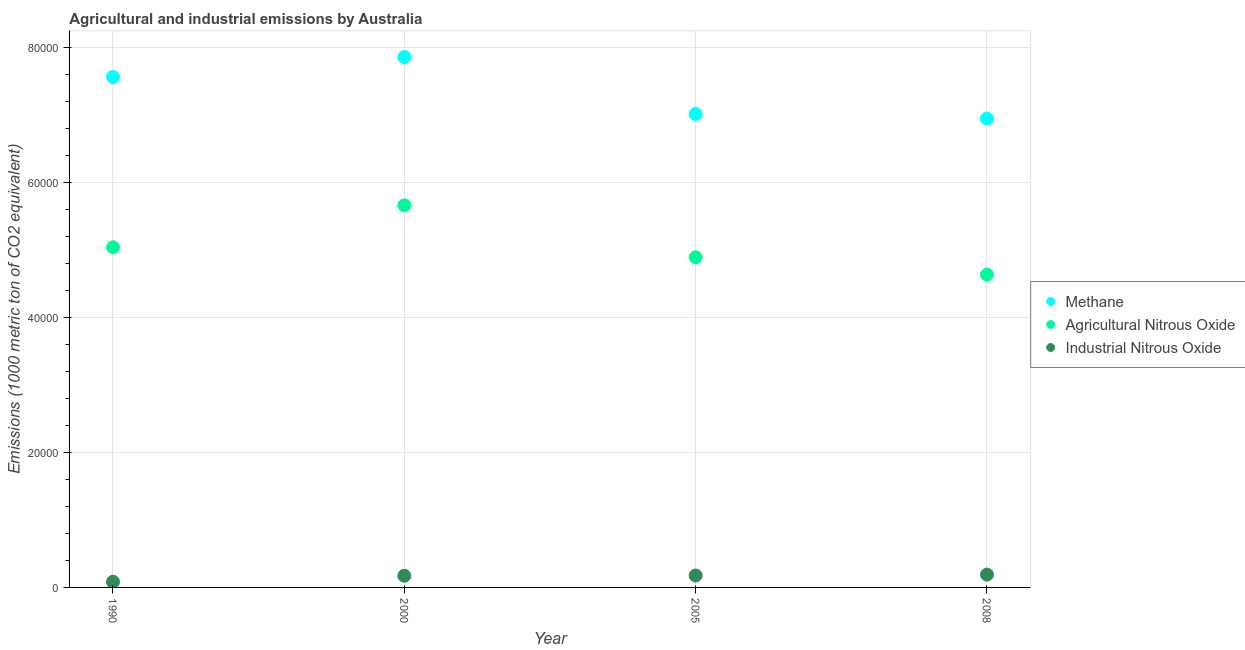How many different coloured dotlines are there?
Make the answer very short. 3. What is the amount of industrial nitrous oxide emissions in 2008?
Provide a short and direct response. 1903.1. Across all years, what is the maximum amount of methane emissions?
Make the answer very short. 7.85e+04. Across all years, what is the minimum amount of industrial nitrous oxide emissions?
Give a very brief answer. 839.8. In which year was the amount of methane emissions minimum?
Make the answer very short. 2008. What is the total amount of methane emissions in the graph?
Offer a terse response. 2.94e+05. What is the difference between the amount of industrial nitrous oxide emissions in 2000 and that in 2008?
Offer a very short reply. -173.3. What is the difference between the amount of agricultural nitrous oxide emissions in 2005 and the amount of methane emissions in 2008?
Your response must be concise. -2.05e+04. What is the average amount of industrial nitrous oxide emissions per year?
Ensure brevity in your answer.  1559.55. In the year 2005, what is the difference between the amount of agricultural nitrous oxide emissions and amount of industrial nitrous oxide emissions?
Provide a short and direct response. 4.71e+04. What is the ratio of the amount of agricultural nitrous oxide emissions in 2000 to that in 2005?
Your response must be concise. 1.16. Is the difference between the amount of agricultural nitrous oxide emissions in 2000 and 2008 greater than the difference between the amount of industrial nitrous oxide emissions in 2000 and 2008?
Offer a very short reply. Yes. What is the difference between the highest and the second highest amount of methane emissions?
Provide a succinct answer. 2952.5. What is the difference between the highest and the lowest amount of agricultural nitrous oxide emissions?
Offer a very short reply. 1.03e+04. In how many years, is the amount of industrial nitrous oxide emissions greater than the average amount of industrial nitrous oxide emissions taken over all years?
Provide a succinct answer. 3. Is the sum of the amount of agricultural nitrous oxide emissions in 2000 and 2005 greater than the maximum amount of methane emissions across all years?
Offer a very short reply. Yes. Is it the case that in every year, the sum of the amount of methane emissions and amount of agricultural nitrous oxide emissions is greater than the amount of industrial nitrous oxide emissions?
Your answer should be very brief. Yes. Is the amount of methane emissions strictly greater than the amount of industrial nitrous oxide emissions over the years?
Provide a short and direct response. Yes. How many dotlines are there?
Ensure brevity in your answer.  3. How many years are there in the graph?
Provide a short and direct response. 4. What is the difference between two consecutive major ticks on the Y-axis?
Provide a succinct answer. 2.00e+04. How many legend labels are there?
Make the answer very short. 3. How are the legend labels stacked?
Your answer should be very brief. Vertical. What is the title of the graph?
Provide a short and direct response. Agricultural and industrial emissions by Australia. What is the label or title of the Y-axis?
Your answer should be very brief. Emissions (1000 metric ton of CO2 equivalent). What is the Emissions (1000 metric ton of CO2 equivalent) of Methane in 1990?
Ensure brevity in your answer.  7.56e+04. What is the Emissions (1000 metric ton of CO2 equivalent) in Agricultural Nitrous Oxide in 1990?
Provide a short and direct response. 5.04e+04. What is the Emissions (1000 metric ton of CO2 equivalent) of Industrial Nitrous Oxide in 1990?
Provide a succinct answer. 839.8. What is the Emissions (1000 metric ton of CO2 equivalent) in Methane in 2000?
Ensure brevity in your answer.  7.85e+04. What is the Emissions (1000 metric ton of CO2 equivalent) in Agricultural Nitrous Oxide in 2000?
Your response must be concise. 5.66e+04. What is the Emissions (1000 metric ton of CO2 equivalent) in Industrial Nitrous Oxide in 2000?
Ensure brevity in your answer.  1729.8. What is the Emissions (1000 metric ton of CO2 equivalent) of Methane in 2005?
Provide a succinct answer. 7.01e+04. What is the Emissions (1000 metric ton of CO2 equivalent) of Agricultural Nitrous Oxide in 2005?
Your response must be concise. 4.89e+04. What is the Emissions (1000 metric ton of CO2 equivalent) in Industrial Nitrous Oxide in 2005?
Your answer should be very brief. 1765.5. What is the Emissions (1000 metric ton of CO2 equivalent) in Methane in 2008?
Offer a terse response. 6.95e+04. What is the Emissions (1000 metric ton of CO2 equivalent) of Agricultural Nitrous Oxide in 2008?
Your answer should be compact. 4.63e+04. What is the Emissions (1000 metric ton of CO2 equivalent) of Industrial Nitrous Oxide in 2008?
Give a very brief answer. 1903.1. Across all years, what is the maximum Emissions (1000 metric ton of CO2 equivalent) in Methane?
Ensure brevity in your answer.  7.85e+04. Across all years, what is the maximum Emissions (1000 metric ton of CO2 equivalent) of Agricultural Nitrous Oxide?
Offer a very short reply. 5.66e+04. Across all years, what is the maximum Emissions (1000 metric ton of CO2 equivalent) of Industrial Nitrous Oxide?
Keep it short and to the point. 1903.1. Across all years, what is the minimum Emissions (1000 metric ton of CO2 equivalent) of Methane?
Your answer should be very brief. 6.95e+04. Across all years, what is the minimum Emissions (1000 metric ton of CO2 equivalent) in Agricultural Nitrous Oxide?
Offer a very short reply. 4.63e+04. Across all years, what is the minimum Emissions (1000 metric ton of CO2 equivalent) of Industrial Nitrous Oxide?
Your answer should be very brief. 839.8. What is the total Emissions (1000 metric ton of CO2 equivalent) of Methane in the graph?
Give a very brief answer. 2.94e+05. What is the total Emissions (1000 metric ton of CO2 equivalent) of Agricultural Nitrous Oxide in the graph?
Give a very brief answer. 2.02e+05. What is the total Emissions (1000 metric ton of CO2 equivalent) of Industrial Nitrous Oxide in the graph?
Keep it short and to the point. 6238.2. What is the difference between the Emissions (1000 metric ton of CO2 equivalent) of Methane in 1990 and that in 2000?
Make the answer very short. -2952.5. What is the difference between the Emissions (1000 metric ton of CO2 equivalent) of Agricultural Nitrous Oxide in 1990 and that in 2000?
Provide a succinct answer. -6212.8. What is the difference between the Emissions (1000 metric ton of CO2 equivalent) in Industrial Nitrous Oxide in 1990 and that in 2000?
Give a very brief answer. -890. What is the difference between the Emissions (1000 metric ton of CO2 equivalent) of Methane in 1990 and that in 2005?
Provide a short and direct response. 5478.7. What is the difference between the Emissions (1000 metric ton of CO2 equivalent) in Agricultural Nitrous Oxide in 1990 and that in 2005?
Your answer should be very brief. 1475.2. What is the difference between the Emissions (1000 metric ton of CO2 equivalent) in Industrial Nitrous Oxide in 1990 and that in 2005?
Provide a short and direct response. -925.7. What is the difference between the Emissions (1000 metric ton of CO2 equivalent) in Methane in 1990 and that in 2008?
Your answer should be compact. 6145.3. What is the difference between the Emissions (1000 metric ton of CO2 equivalent) in Agricultural Nitrous Oxide in 1990 and that in 2008?
Your answer should be compact. 4045.5. What is the difference between the Emissions (1000 metric ton of CO2 equivalent) of Industrial Nitrous Oxide in 1990 and that in 2008?
Your answer should be very brief. -1063.3. What is the difference between the Emissions (1000 metric ton of CO2 equivalent) in Methane in 2000 and that in 2005?
Provide a short and direct response. 8431.2. What is the difference between the Emissions (1000 metric ton of CO2 equivalent) in Agricultural Nitrous Oxide in 2000 and that in 2005?
Provide a succinct answer. 7688. What is the difference between the Emissions (1000 metric ton of CO2 equivalent) in Industrial Nitrous Oxide in 2000 and that in 2005?
Provide a succinct answer. -35.7. What is the difference between the Emissions (1000 metric ton of CO2 equivalent) in Methane in 2000 and that in 2008?
Your answer should be very brief. 9097.8. What is the difference between the Emissions (1000 metric ton of CO2 equivalent) of Agricultural Nitrous Oxide in 2000 and that in 2008?
Ensure brevity in your answer.  1.03e+04. What is the difference between the Emissions (1000 metric ton of CO2 equivalent) in Industrial Nitrous Oxide in 2000 and that in 2008?
Provide a succinct answer. -173.3. What is the difference between the Emissions (1000 metric ton of CO2 equivalent) of Methane in 2005 and that in 2008?
Your answer should be compact. 666.6. What is the difference between the Emissions (1000 metric ton of CO2 equivalent) of Agricultural Nitrous Oxide in 2005 and that in 2008?
Give a very brief answer. 2570.3. What is the difference between the Emissions (1000 metric ton of CO2 equivalent) of Industrial Nitrous Oxide in 2005 and that in 2008?
Your answer should be compact. -137.6. What is the difference between the Emissions (1000 metric ton of CO2 equivalent) in Methane in 1990 and the Emissions (1000 metric ton of CO2 equivalent) in Agricultural Nitrous Oxide in 2000?
Your response must be concise. 1.90e+04. What is the difference between the Emissions (1000 metric ton of CO2 equivalent) of Methane in 1990 and the Emissions (1000 metric ton of CO2 equivalent) of Industrial Nitrous Oxide in 2000?
Offer a very short reply. 7.39e+04. What is the difference between the Emissions (1000 metric ton of CO2 equivalent) of Agricultural Nitrous Oxide in 1990 and the Emissions (1000 metric ton of CO2 equivalent) of Industrial Nitrous Oxide in 2000?
Your response must be concise. 4.86e+04. What is the difference between the Emissions (1000 metric ton of CO2 equivalent) in Methane in 1990 and the Emissions (1000 metric ton of CO2 equivalent) in Agricultural Nitrous Oxide in 2005?
Your answer should be compact. 2.67e+04. What is the difference between the Emissions (1000 metric ton of CO2 equivalent) of Methane in 1990 and the Emissions (1000 metric ton of CO2 equivalent) of Industrial Nitrous Oxide in 2005?
Offer a very short reply. 7.38e+04. What is the difference between the Emissions (1000 metric ton of CO2 equivalent) in Agricultural Nitrous Oxide in 1990 and the Emissions (1000 metric ton of CO2 equivalent) in Industrial Nitrous Oxide in 2005?
Offer a very short reply. 4.86e+04. What is the difference between the Emissions (1000 metric ton of CO2 equivalent) in Methane in 1990 and the Emissions (1000 metric ton of CO2 equivalent) in Agricultural Nitrous Oxide in 2008?
Offer a very short reply. 2.93e+04. What is the difference between the Emissions (1000 metric ton of CO2 equivalent) in Methane in 1990 and the Emissions (1000 metric ton of CO2 equivalent) in Industrial Nitrous Oxide in 2008?
Offer a very short reply. 7.37e+04. What is the difference between the Emissions (1000 metric ton of CO2 equivalent) of Agricultural Nitrous Oxide in 1990 and the Emissions (1000 metric ton of CO2 equivalent) of Industrial Nitrous Oxide in 2008?
Your response must be concise. 4.85e+04. What is the difference between the Emissions (1000 metric ton of CO2 equivalent) in Methane in 2000 and the Emissions (1000 metric ton of CO2 equivalent) in Agricultural Nitrous Oxide in 2005?
Offer a very short reply. 2.96e+04. What is the difference between the Emissions (1000 metric ton of CO2 equivalent) of Methane in 2000 and the Emissions (1000 metric ton of CO2 equivalent) of Industrial Nitrous Oxide in 2005?
Keep it short and to the point. 7.68e+04. What is the difference between the Emissions (1000 metric ton of CO2 equivalent) in Agricultural Nitrous Oxide in 2000 and the Emissions (1000 metric ton of CO2 equivalent) in Industrial Nitrous Oxide in 2005?
Give a very brief answer. 5.48e+04. What is the difference between the Emissions (1000 metric ton of CO2 equivalent) of Methane in 2000 and the Emissions (1000 metric ton of CO2 equivalent) of Agricultural Nitrous Oxide in 2008?
Provide a short and direct response. 3.22e+04. What is the difference between the Emissions (1000 metric ton of CO2 equivalent) of Methane in 2000 and the Emissions (1000 metric ton of CO2 equivalent) of Industrial Nitrous Oxide in 2008?
Your answer should be very brief. 7.66e+04. What is the difference between the Emissions (1000 metric ton of CO2 equivalent) in Agricultural Nitrous Oxide in 2000 and the Emissions (1000 metric ton of CO2 equivalent) in Industrial Nitrous Oxide in 2008?
Provide a short and direct response. 5.47e+04. What is the difference between the Emissions (1000 metric ton of CO2 equivalent) in Methane in 2005 and the Emissions (1000 metric ton of CO2 equivalent) in Agricultural Nitrous Oxide in 2008?
Ensure brevity in your answer.  2.38e+04. What is the difference between the Emissions (1000 metric ton of CO2 equivalent) of Methane in 2005 and the Emissions (1000 metric ton of CO2 equivalent) of Industrial Nitrous Oxide in 2008?
Make the answer very short. 6.82e+04. What is the difference between the Emissions (1000 metric ton of CO2 equivalent) of Agricultural Nitrous Oxide in 2005 and the Emissions (1000 metric ton of CO2 equivalent) of Industrial Nitrous Oxide in 2008?
Keep it short and to the point. 4.70e+04. What is the average Emissions (1000 metric ton of CO2 equivalent) of Methane per year?
Your answer should be very brief. 7.34e+04. What is the average Emissions (1000 metric ton of CO2 equivalent) in Agricultural Nitrous Oxide per year?
Offer a very short reply. 5.06e+04. What is the average Emissions (1000 metric ton of CO2 equivalent) of Industrial Nitrous Oxide per year?
Offer a very short reply. 1559.55. In the year 1990, what is the difference between the Emissions (1000 metric ton of CO2 equivalent) of Methane and Emissions (1000 metric ton of CO2 equivalent) of Agricultural Nitrous Oxide?
Provide a succinct answer. 2.52e+04. In the year 1990, what is the difference between the Emissions (1000 metric ton of CO2 equivalent) of Methane and Emissions (1000 metric ton of CO2 equivalent) of Industrial Nitrous Oxide?
Ensure brevity in your answer.  7.48e+04. In the year 1990, what is the difference between the Emissions (1000 metric ton of CO2 equivalent) in Agricultural Nitrous Oxide and Emissions (1000 metric ton of CO2 equivalent) in Industrial Nitrous Oxide?
Offer a very short reply. 4.95e+04. In the year 2000, what is the difference between the Emissions (1000 metric ton of CO2 equivalent) of Methane and Emissions (1000 metric ton of CO2 equivalent) of Agricultural Nitrous Oxide?
Your answer should be very brief. 2.20e+04. In the year 2000, what is the difference between the Emissions (1000 metric ton of CO2 equivalent) of Methane and Emissions (1000 metric ton of CO2 equivalent) of Industrial Nitrous Oxide?
Make the answer very short. 7.68e+04. In the year 2000, what is the difference between the Emissions (1000 metric ton of CO2 equivalent) in Agricultural Nitrous Oxide and Emissions (1000 metric ton of CO2 equivalent) in Industrial Nitrous Oxide?
Give a very brief answer. 5.49e+04. In the year 2005, what is the difference between the Emissions (1000 metric ton of CO2 equivalent) of Methane and Emissions (1000 metric ton of CO2 equivalent) of Agricultural Nitrous Oxide?
Ensure brevity in your answer.  2.12e+04. In the year 2005, what is the difference between the Emissions (1000 metric ton of CO2 equivalent) in Methane and Emissions (1000 metric ton of CO2 equivalent) in Industrial Nitrous Oxide?
Provide a short and direct response. 6.84e+04. In the year 2005, what is the difference between the Emissions (1000 metric ton of CO2 equivalent) in Agricultural Nitrous Oxide and Emissions (1000 metric ton of CO2 equivalent) in Industrial Nitrous Oxide?
Make the answer very short. 4.71e+04. In the year 2008, what is the difference between the Emissions (1000 metric ton of CO2 equivalent) in Methane and Emissions (1000 metric ton of CO2 equivalent) in Agricultural Nitrous Oxide?
Your response must be concise. 2.31e+04. In the year 2008, what is the difference between the Emissions (1000 metric ton of CO2 equivalent) of Methane and Emissions (1000 metric ton of CO2 equivalent) of Industrial Nitrous Oxide?
Your answer should be compact. 6.75e+04. In the year 2008, what is the difference between the Emissions (1000 metric ton of CO2 equivalent) in Agricultural Nitrous Oxide and Emissions (1000 metric ton of CO2 equivalent) in Industrial Nitrous Oxide?
Offer a terse response. 4.44e+04. What is the ratio of the Emissions (1000 metric ton of CO2 equivalent) in Methane in 1990 to that in 2000?
Give a very brief answer. 0.96. What is the ratio of the Emissions (1000 metric ton of CO2 equivalent) of Agricultural Nitrous Oxide in 1990 to that in 2000?
Ensure brevity in your answer.  0.89. What is the ratio of the Emissions (1000 metric ton of CO2 equivalent) in Industrial Nitrous Oxide in 1990 to that in 2000?
Your response must be concise. 0.49. What is the ratio of the Emissions (1000 metric ton of CO2 equivalent) of Methane in 1990 to that in 2005?
Your response must be concise. 1.08. What is the ratio of the Emissions (1000 metric ton of CO2 equivalent) in Agricultural Nitrous Oxide in 1990 to that in 2005?
Your response must be concise. 1.03. What is the ratio of the Emissions (1000 metric ton of CO2 equivalent) of Industrial Nitrous Oxide in 1990 to that in 2005?
Your answer should be compact. 0.48. What is the ratio of the Emissions (1000 metric ton of CO2 equivalent) of Methane in 1990 to that in 2008?
Provide a succinct answer. 1.09. What is the ratio of the Emissions (1000 metric ton of CO2 equivalent) of Agricultural Nitrous Oxide in 1990 to that in 2008?
Make the answer very short. 1.09. What is the ratio of the Emissions (1000 metric ton of CO2 equivalent) in Industrial Nitrous Oxide in 1990 to that in 2008?
Offer a very short reply. 0.44. What is the ratio of the Emissions (1000 metric ton of CO2 equivalent) in Methane in 2000 to that in 2005?
Keep it short and to the point. 1.12. What is the ratio of the Emissions (1000 metric ton of CO2 equivalent) of Agricultural Nitrous Oxide in 2000 to that in 2005?
Provide a short and direct response. 1.16. What is the ratio of the Emissions (1000 metric ton of CO2 equivalent) in Industrial Nitrous Oxide in 2000 to that in 2005?
Offer a terse response. 0.98. What is the ratio of the Emissions (1000 metric ton of CO2 equivalent) in Methane in 2000 to that in 2008?
Your answer should be very brief. 1.13. What is the ratio of the Emissions (1000 metric ton of CO2 equivalent) of Agricultural Nitrous Oxide in 2000 to that in 2008?
Your answer should be very brief. 1.22. What is the ratio of the Emissions (1000 metric ton of CO2 equivalent) in Industrial Nitrous Oxide in 2000 to that in 2008?
Keep it short and to the point. 0.91. What is the ratio of the Emissions (1000 metric ton of CO2 equivalent) of Methane in 2005 to that in 2008?
Provide a short and direct response. 1.01. What is the ratio of the Emissions (1000 metric ton of CO2 equivalent) of Agricultural Nitrous Oxide in 2005 to that in 2008?
Offer a very short reply. 1.06. What is the ratio of the Emissions (1000 metric ton of CO2 equivalent) in Industrial Nitrous Oxide in 2005 to that in 2008?
Offer a terse response. 0.93. What is the difference between the highest and the second highest Emissions (1000 metric ton of CO2 equivalent) of Methane?
Keep it short and to the point. 2952.5. What is the difference between the highest and the second highest Emissions (1000 metric ton of CO2 equivalent) of Agricultural Nitrous Oxide?
Give a very brief answer. 6212.8. What is the difference between the highest and the second highest Emissions (1000 metric ton of CO2 equivalent) in Industrial Nitrous Oxide?
Provide a succinct answer. 137.6. What is the difference between the highest and the lowest Emissions (1000 metric ton of CO2 equivalent) in Methane?
Ensure brevity in your answer.  9097.8. What is the difference between the highest and the lowest Emissions (1000 metric ton of CO2 equivalent) in Agricultural Nitrous Oxide?
Offer a terse response. 1.03e+04. What is the difference between the highest and the lowest Emissions (1000 metric ton of CO2 equivalent) in Industrial Nitrous Oxide?
Make the answer very short. 1063.3. 